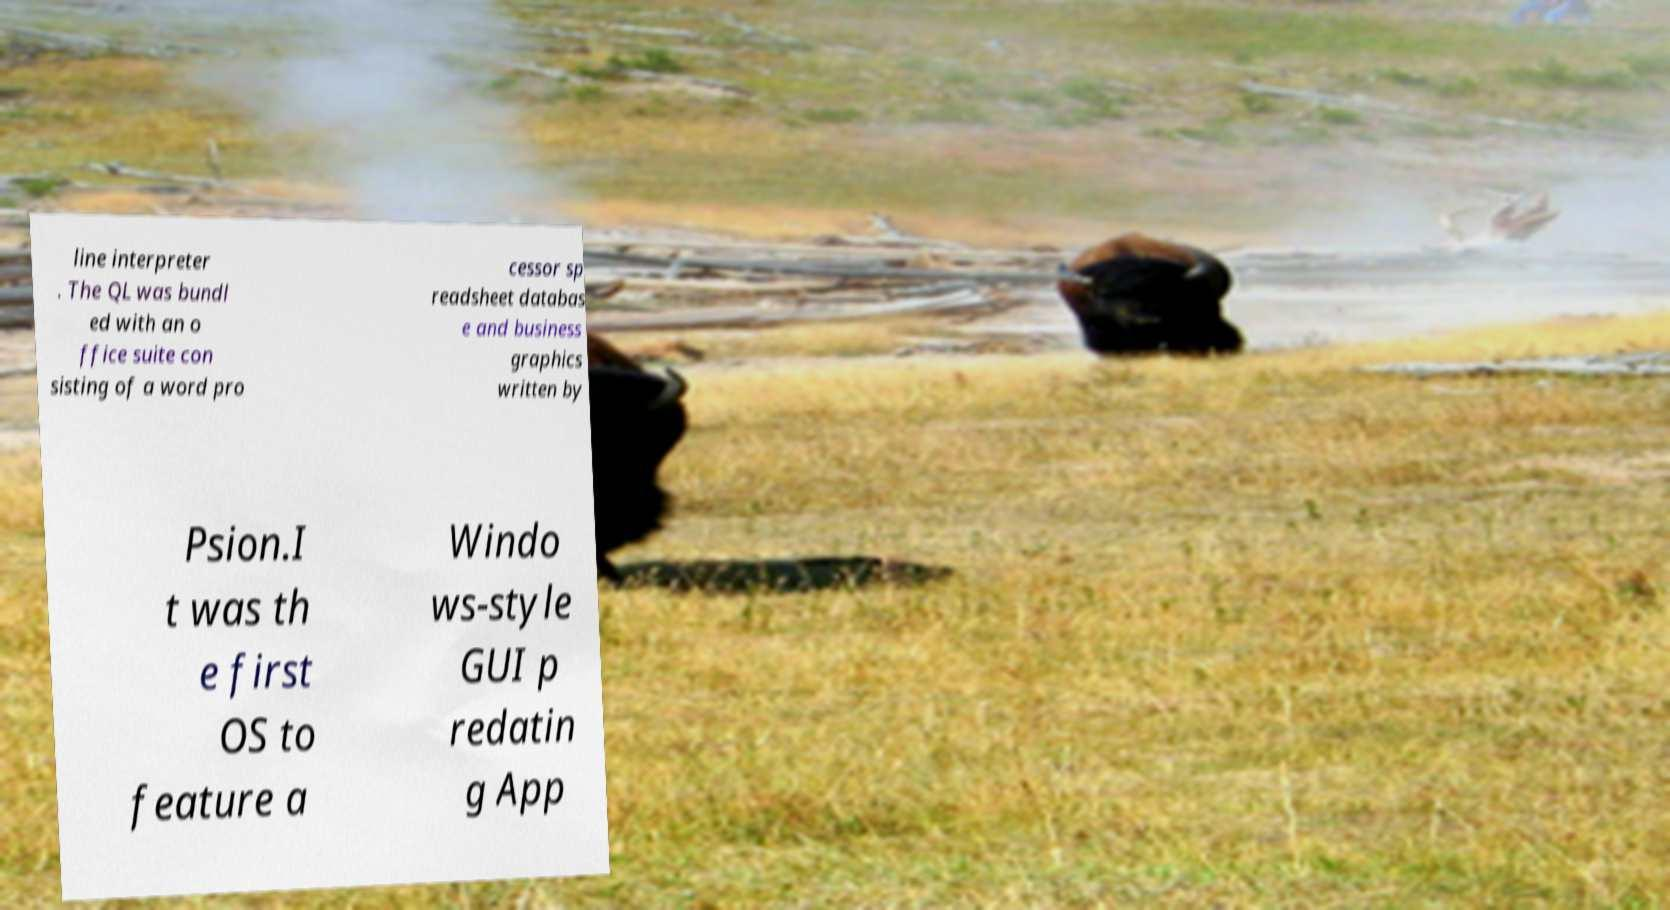There's text embedded in this image that I need extracted. Can you transcribe it verbatim? line interpreter . The QL was bundl ed with an o ffice suite con sisting of a word pro cessor sp readsheet databas e and business graphics written by Psion.I t was th e first OS to feature a Windo ws-style GUI p redatin g App 